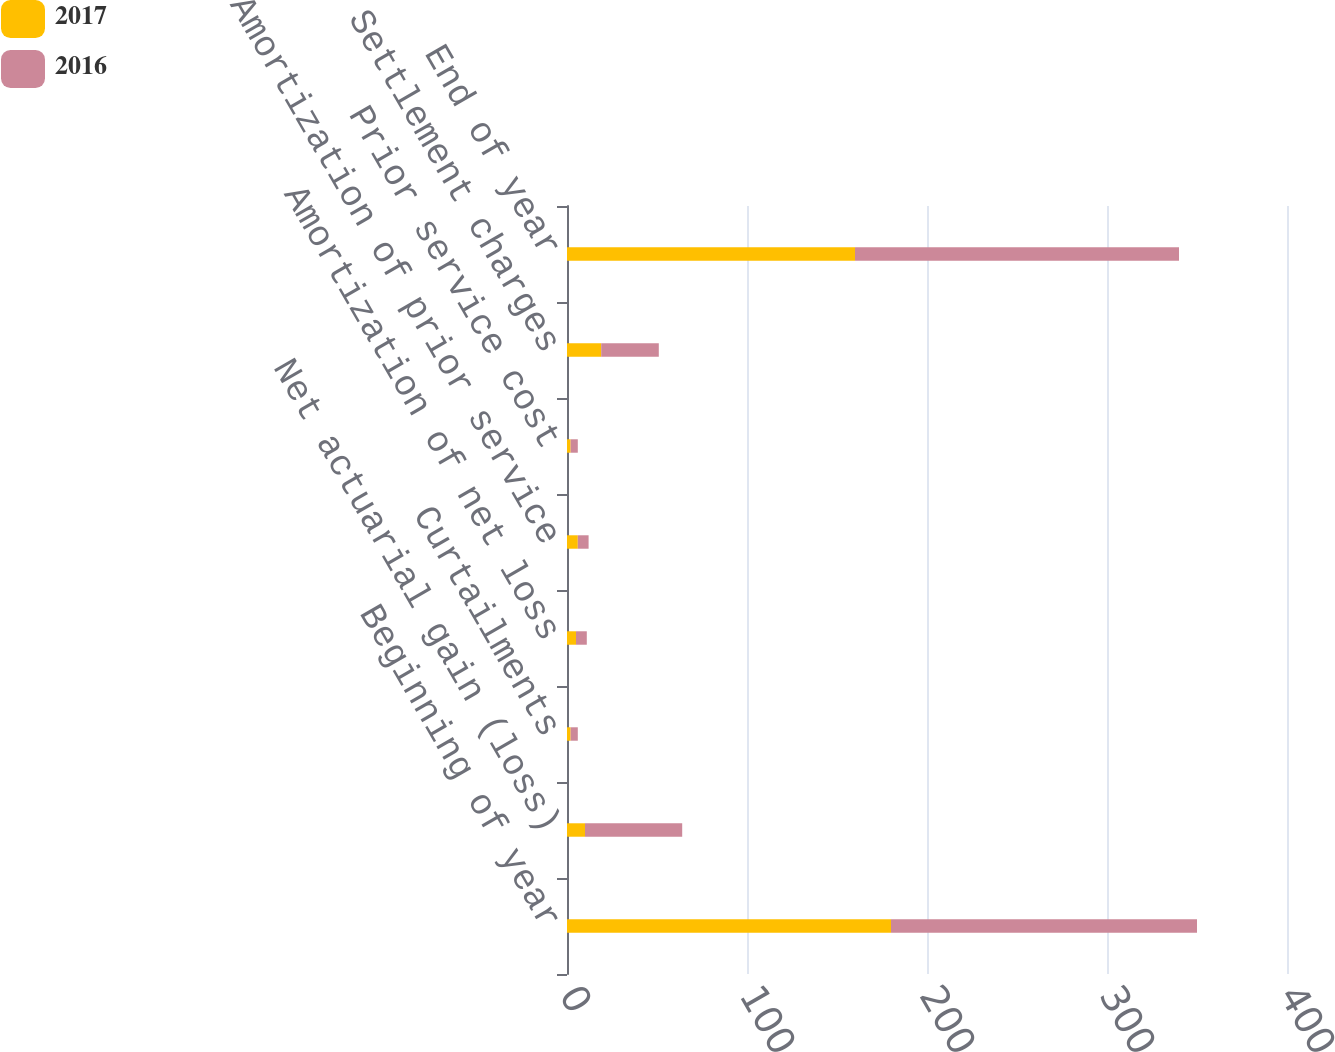Convert chart. <chart><loc_0><loc_0><loc_500><loc_500><stacked_bar_chart><ecel><fcel>Beginning of year<fcel>Net actuarial gain (loss)<fcel>Curtailments<fcel>Amortization of net loss<fcel>Amortization of prior service<fcel>Prior service cost<fcel>Settlement charges<fcel>End of year<nl><fcel>2017<fcel>180<fcel>10<fcel>2<fcel>5<fcel>6<fcel>2<fcel>19<fcel>160<nl><fcel>2016<fcel>170<fcel>54<fcel>4<fcel>6<fcel>6<fcel>4<fcel>32<fcel>180<nl></chart> 